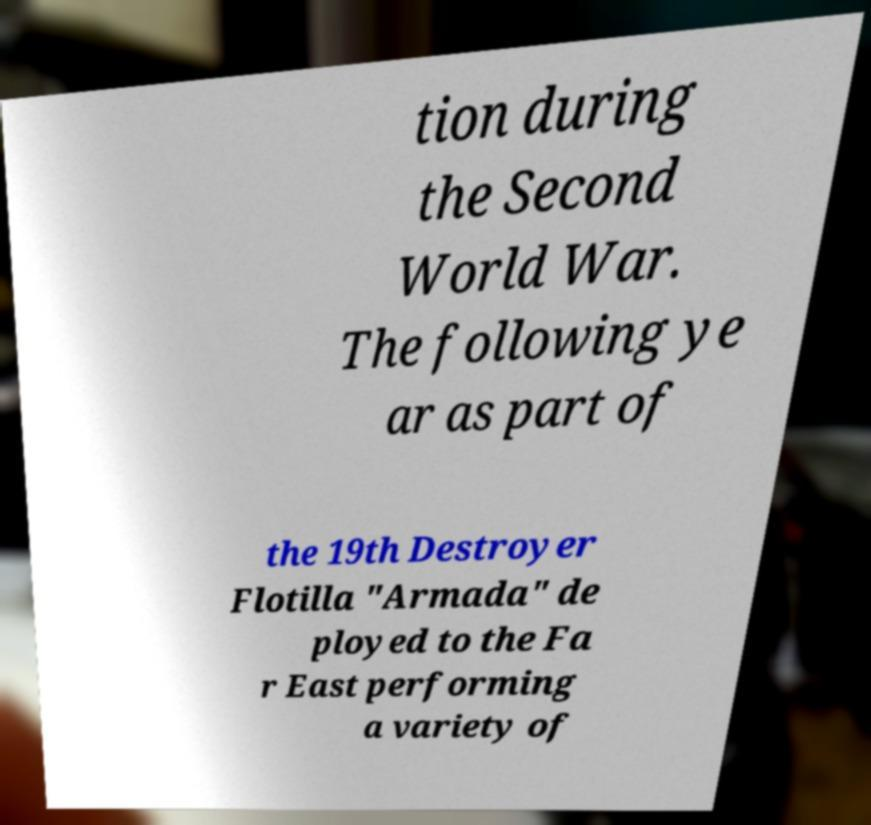I need the written content from this picture converted into text. Can you do that? tion during the Second World War. The following ye ar as part of the 19th Destroyer Flotilla "Armada" de ployed to the Fa r East performing a variety of 